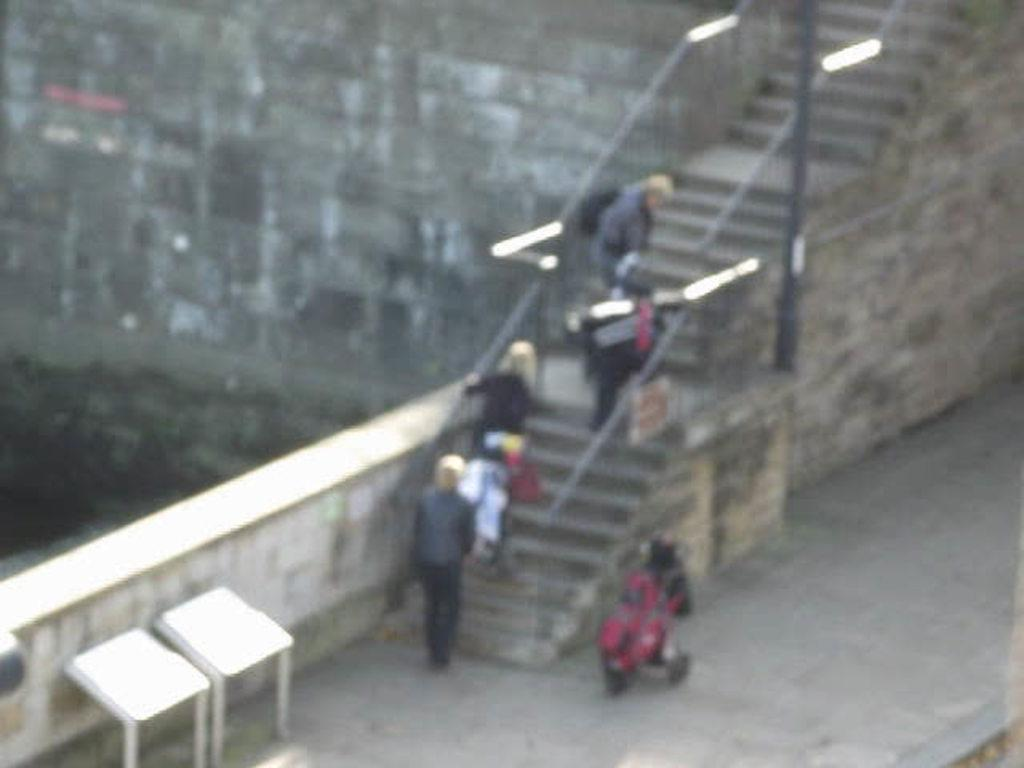Who is in the image? There are old women in the image. What are the old women doing? The old women are climbing stairs. What objects can be seen at the bottom of the image? There are two tables at the bottom of the image. What is visible in the background of the image? There is a big granite wall in the background of the image. Can you see any trays being carried by the old women in the image? There is no mention of trays in the image, so it cannot be determined if the old women are carrying any. 